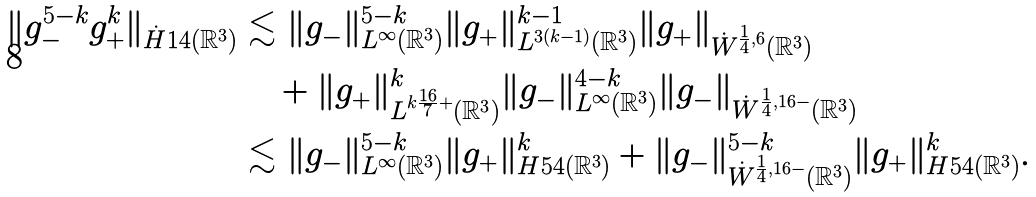Convert formula to latex. <formula><loc_0><loc_0><loc_500><loc_500>\| g _ { - } ^ { 5 - k } g _ { + } ^ { k } \| _ { \dot { H } ^ { } { 1 } 4 ( \mathbb { R } ^ { 3 } ) } & \lesssim \| g _ { - } \| _ { L ^ { \infty } ( \mathbb { R } ^ { 3 } ) } ^ { 5 - k } \| g _ { + } \| _ { L ^ { 3 ( k - 1 ) } ( \mathbb { R } ^ { 3 } ) } ^ { k - 1 } \| g _ { + } \| _ { \dot { W } ^ { \frac { 1 } { 4 } , 6 } ( \mathbb { R } ^ { 3 } ) } \\ & \quad + \| g _ { + } \| _ { L ^ { k \frac { 1 6 } { 7 } + } ( \mathbb { R } ^ { 3 } ) } ^ { k } \| g _ { - } \| _ { L ^ { \infty } ( \mathbb { R } ^ { 3 } ) } ^ { 4 - k } \| g _ { - } \| _ { \dot { W } ^ { \frac { 1 } { 4 } , 1 6 - } ( \mathbb { R } ^ { 3 } ) } \\ & \lesssim \| g _ { - } \| _ { L ^ { \infty } ( \mathbb { R } ^ { 3 } ) } ^ { 5 - k } \| g _ { + } \| _ { H ^ { } { 5 } 4 ( \mathbb { R } ^ { 3 } ) } ^ { k } + \| g _ { - } \| _ { \dot { W } ^ { \frac { 1 } { 4 } , 1 6 - } ( \mathbb { R } ^ { 3 } ) } ^ { 5 - k } \| g _ { + } \| _ { H ^ { } { 5 } 4 ( \mathbb { R } ^ { 3 } ) } ^ { k } .</formula> 